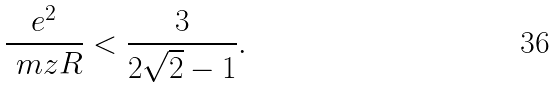<formula> <loc_0><loc_0><loc_500><loc_500>\frac { e ^ { 2 } } { \ m z R } < \frac { 3 } { 2 \sqrt { 2 } - 1 } .</formula> 